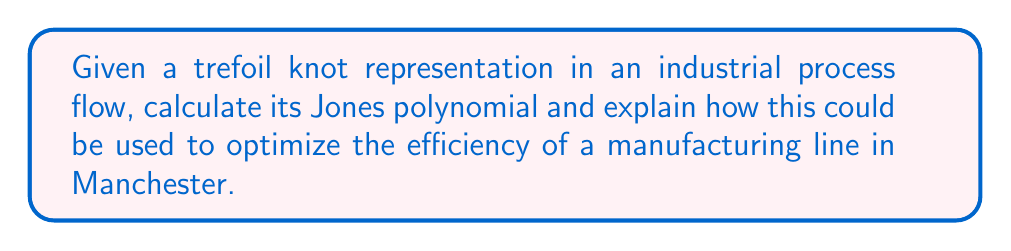Show me your answer to this math problem. Step 1: Understand the trefoil knot representation
The trefoil knot is one of the simplest non-trivial knots, often used to model complex process flows in industrial engineering.

Step 2: Calculate the Jones polynomial
For a trefoil knot, the Jones polynomial is given by:

$$ V(t) = t + t^3 - t^4 $$

Step 3: Analyze the polynomial
The terms in the Jones polynomial represent different levels of complexity in the process:
- $t$ represents simple linear processes
- $t^3$ represents moderately complex interactions
- $-t^4$ represents highly complex, potentially inefficient processes

Step 4: Relate to industrial process optimization
In a manufacturing line, we can interpret these terms as follows:
- Linear processes ($t$): Direct, efficient steps
- Moderate complexity ($t^3$): Necessary but more involved processes
- High complexity ($-t^4$): Potential bottlenecks or inefficiencies

Step 5: Application to Manchester manufacturing
For a Manchester-based manufacturing line, we could:
1. Identify processes corresponding to each term
2. Focus on reducing or eliminating $-t^4$ processes
3. Optimize $t^3$ processes where possible
4. Maximize the efficiency of $t$ processes

Step 6: Data-driven approach
Collect data on process times and resource utilization for each identified step. Use this data to:
1. Quantify the impact of each polynomial term on overall efficiency
2. Set KPIs for process improvement based on reducing higher-order terms
3. Implement lean manufacturing principles to streamline complex processes

Step 7: Continuous improvement
Regularly recalculate the Jones polynomial of the optimized process to ensure ongoing efficiency gains and adapt to changes in the manufacturing environment.
Answer: $V(t) = t + t^3 - t^4$; Optimize by reducing $-t^4$ processes, streamlining $t^3$ processes, and maximizing $t$ processes based on data-driven analysis. 